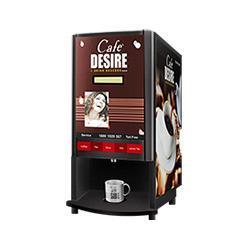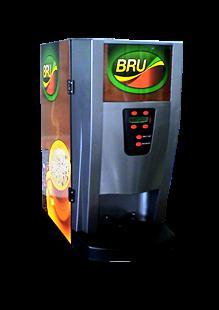The first image is the image on the left, the second image is the image on the right. For the images displayed, is the sentence "In one image the coffee maker is open." factually correct? Answer yes or no. No. 